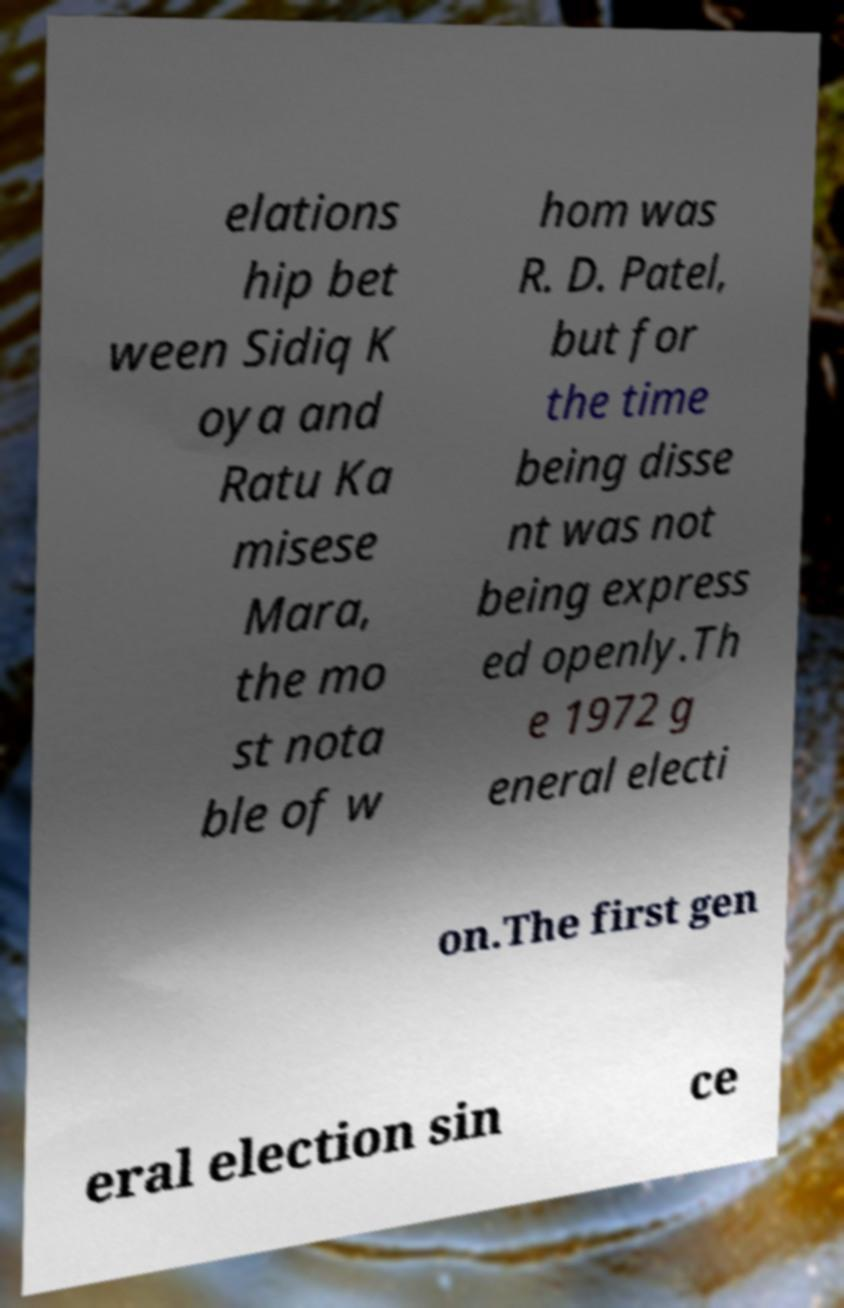Please read and relay the text visible in this image. What does it say? elations hip bet ween Sidiq K oya and Ratu Ka misese Mara, the mo st nota ble of w hom was R. D. Patel, but for the time being disse nt was not being express ed openly.Th e 1972 g eneral electi on.The first gen eral election sin ce 